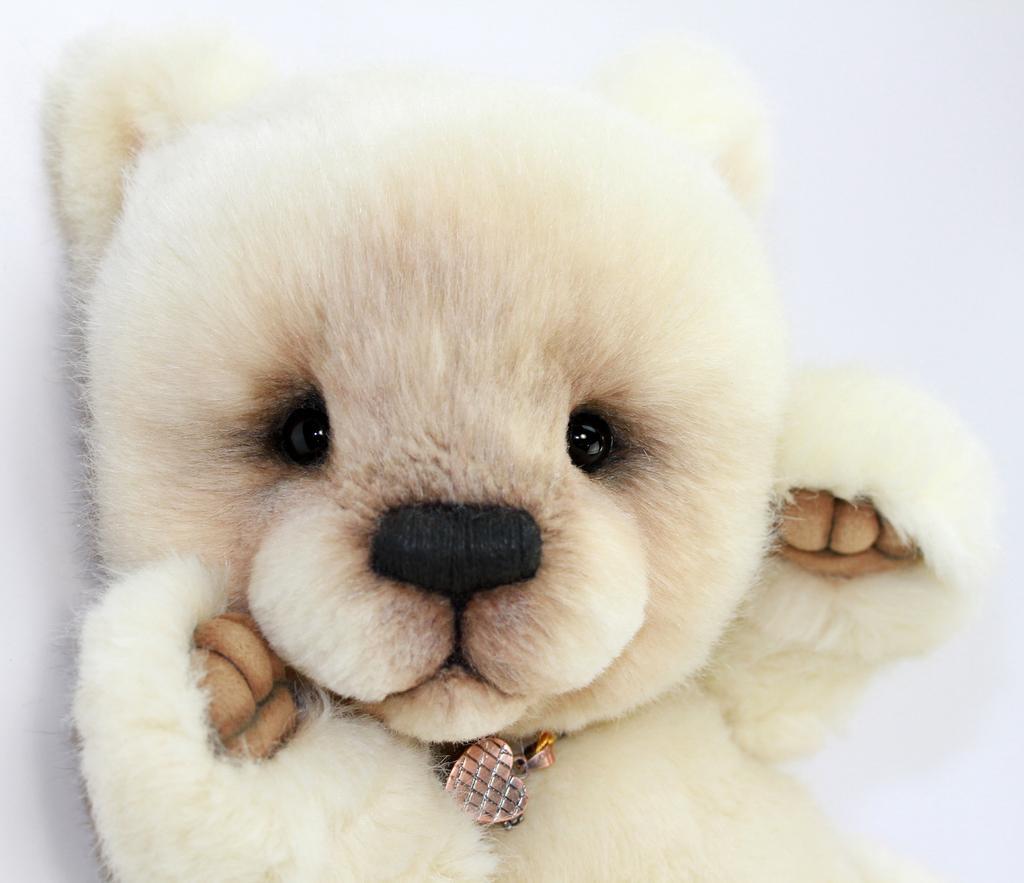Describe this image in one or two sentences. In this image I can see a teddy-bear which is in white and black color. Background is in white color. 